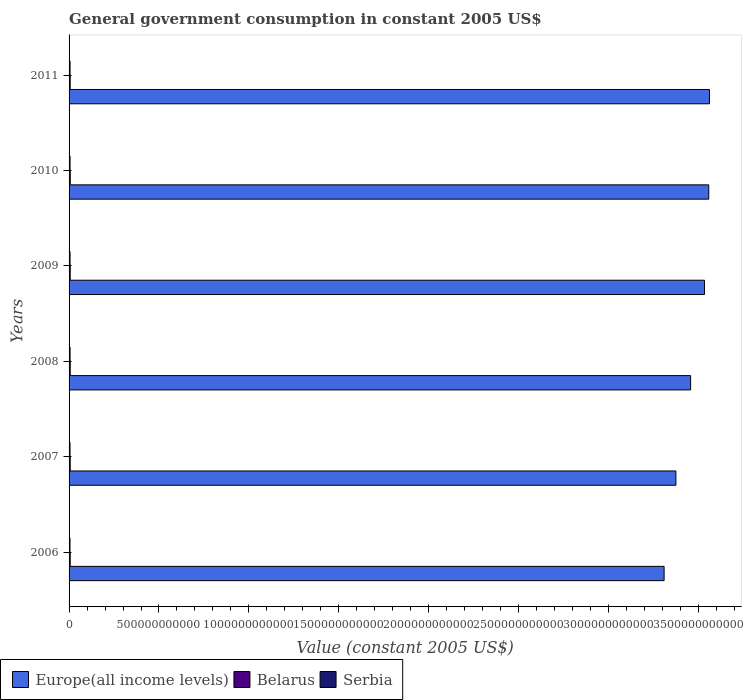How many different coloured bars are there?
Provide a short and direct response. 3. Are the number of bars per tick equal to the number of legend labels?
Offer a very short reply. Yes. How many bars are there on the 2nd tick from the top?
Your answer should be very brief. 3. How many bars are there on the 5th tick from the bottom?
Ensure brevity in your answer.  3. What is the label of the 3rd group of bars from the top?
Provide a succinct answer. 2009. What is the government conusmption in Europe(all income levels) in 2009?
Offer a terse response. 3.53e+12. Across all years, what is the maximum government conusmption in Belarus?
Offer a terse response. 6.45e+09. Across all years, what is the minimum government conusmption in Belarus?
Ensure brevity in your answer.  6.22e+09. In which year was the government conusmption in Europe(all income levels) minimum?
Offer a very short reply. 2006. What is the total government conusmption in Belarus in the graph?
Ensure brevity in your answer.  3.77e+1. What is the difference between the government conusmption in Serbia in 2006 and that in 2011?
Keep it short and to the point. -2.69e+08. What is the difference between the government conusmption in Serbia in 2006 and the government conusmption in Europe(all income levels) in 2009?
Keep it short and to the point. -3.53e+12. What is the average government conusmption in Serbia per year?
Provide a short and direct response. 5.38e+09. In the year 2008, what is the difference between the government conusmption in Belarus and government conusmption in Europe(all income levels)?
Give a very brief answer. -3.45e+12. What is the ratio of the government conusmption in Europe(all income levels) in 2009 to that in 2011?
Provide a short and direct response. 0.99. What is the difference between the highest and the second highest government conusmption in Europe(all income levels)?
Keep it short and to the point. 4.00e+09. What is the difference between the highest and the lowest government conusmption in Serbia?
Provide a succinct answer. 3.10e+08. In how many years, is the government conusmption in Europe(all income levels) greater than the average government conusmption in Europe(all income levels) taken over all years?
Ensure brevity in your answer.  3. What does the 2nd bar from the top in 2008 represents?
Your answer should be compact. Belarus. What does the 1st bar from the bottom in 2009 represents?
Provide a succinct answer. Europe(all income levels). What is the difference between two consecutive major ticks on the X-axis?
Give a very brief answer. 5.00e+11. Are the values on the major ticks of X-axis written in scientific E-notation?
Keep it short and to the point. No. Does the graph contain any zero values?
Your answer should be very brief. No. Does the graph contain grids?
Your answer should be very brief. No. Where does the legend appear in the graph?
Provide a succinct answer. Bottom left. What is the title of the graph?
Offer a very short reply. General government consumption in constant 2005 US$. What is the label or title of the X-axis?
Make the answer very short. Value (constant 2005 US$). What is the label or title of the Y-axis?
Provide a short and direct response. Years. What is the Value (constant 2005 US$) of Europe(all income levels) in 2006?
Offer a terse response. 3.31e+12. What is the Value (constant 2005 US$) in Belarus in 2006?
Make the answer very short. 6.27e+09. What is the Value (constant 2005 US$) in Serbia in 2006?
Make the answer very short. 5.20e+09. What is the Value (constant 2005 US$) of Europe(all income levels) in 2007?
Give a very brief answer. 3.37e+12. What is the Value (constant 2005 US$) of Belarus in 2007?
Provide a short and direct response. 6.24e+09. What is the Value (constant 2005 US$) in Serbia in 2007?
Give a very brief answer. 5.29e+09. What is the Value (constant 2005 US$) of Europe(all income levels) in 2008?
Ensure brevity in your answer.  3.46e+12. What is the Value (constant 2005 US$) in Belarus in 2008?
Your answer should be compact. 6.26e+09. What is the Value (constant 2005 US$) of Serbia in 2008?
Offer a very short reply. 5.51e+09. What is the Value (constant 2005 US$) of Europe(all income levels) in 2009?
Ensure brevity in your answer.  3.53e+12. What is the Value (constant 2005 US$) in Belarus in 2009?
Ensure brevity in your answer.  6.25e+09. What is the Value (constant 2005 US$) of Serbia in 2009?
Provide a succinct answer. 5.41e+09. What is the Value (constant 2005 US$) of Europe(all income levels) in 2010?
Give a very brief answer. 3.56e+12. What is the Value (constant 2005 US$) of Belarus in 2010?
Your answer should be compact. 6.45e+09. What is the Value (constant 2005 US$) in Serbia in 2010?
Ensure brevity in your answer.  5.42e+09. What is the Value (constant 2005 US$) in Europe(all income levels) in 2011?
Your response must be concise. 3.56e+12. What is the Value (constant 2005 US$) of Belarus in 2011?
Offer a very short reply. 6.22e+09. What is the Value (constant 2005 US$) in Serbia in 2011?
Your answer should be compact. 5.47e+09. Across all years, what is the maximum Value (constant 2005 US$) in Europe(all income levels)?
Offer a very short reply. 3.56e+12. Across all years, what is the maximum Value (constant 2005 US$) of Belarus?
Provide a succinct answer. 6.45e+09. Across all years, what is the maximum Value (constant 2005 US$) of Serbia?
Offer a terse response. 5.51e+09. Across all years, what is the minimum Value (constant 2005 US$) of Europe(all income levels)?
Give a very brief answer. 3.31e+12. Across all years, what is the minimum Value (constant 2005 US$) in Belarus?
Your response must be concise. 6.22e+09. Across all years, what is the minimum Value (constant 2005 US$) in Serbia?
Make the answer very short. 5.20e+09. What is the total Value (constant 2005 US$) of Europe(all income levels) in the graph?
Keep it short and to the point. 2.08e+13. What is the total Value (constant 2005 US$) in Belarus in the graph?
Your answer should be very brief. 3.77e+1. What is the total Value (constant 2005 US$) of Serbia in the graph?
Offer a terse response. 3.23e+1. What is the difference between the Value (constant 2005 US$) in Europe(all income levels) in 2006 and that in 2007?
Give a very brief answer. -6.56e+1. What is the difference between the Value (constant 2005 US$) in Belarus in 2006 and that in 2007?
Give a very brief answer. 3.20e+07. What is the difference between the Value (constant 2005 US$) of Serbia in 2006 and that in 2007?
Provide a short and direct response. -9.74e+07. What is the difference between the Value (constant 2005 US$) in Europe(all income levels) in 2006 and that in 2008?
Make the answer very short. -1.47e+11. What is the difference between the Value (constant 2005 US$) in Belarus in 2006 and that in 2008?
Give a very brief answer. 1.20e+07. What is the difference between the Value (constant 2005 US$) of Serbia in 2006 and that in 2008?
Give a very brief answer. -3.10e+08. What is the difference between the Value (constant 2005 US$) of Europe(all income levels) in 2006 and that in 2009?
Your response must be concise. -2.24e+11. What is the difference between the Value (constant 2005 US$) of Belarus in 2006 and that in 2009?
Provide a short and direct response. 1.70e+07. What is the difference between the Value (constant 2005 US$) in Serbia in 2006 and that in 2009?
Keep it short and to the point. -2.16e+08. What is the difference between the Value (constant 2005 US$) in Europe(all income levels) in 2006 and that in 2010?
Keep it short and to the point. -2.48e+11. What is the difference between the Value (constant 2005 US$) of Belarus in 2006 and that in 2010?
Ensure brevity in your answer.  -1.78e+08. What is the difference between the Value (constant 2005 US$) in Serbia in 2006 and that in 2010?
Keep it short and to the point. -2.20e+08. What is the difference between the Value (constant 2005 US$) in Europe(all income levels) in 2006 and that in 2011?
Give a very brief answer. -2.52e+11. What is the difference between the Value (constant 2005 US$) of Belarus in 2006 and that in 2011?
Offer a very short reply. 5.12e+07. What is the difference between the Value (constant 2005 US$) of Serbia in 2006 and that in 2011?
Offer a very short reply. -2.69e+08. What is the difference between the Value (constant 2005 US$) of Europe(all income levels) in 2007 and that in 2008?
Make the answer very short. -8.17e+1. What is the difference between the Value (constant 2005 US$) in Belarus in 2007 and that in 2008?
Your answer should be very brief. -2.00e+07. What is the difference between the Value (constant 2005 US$) in Serbia in 2007 and that in 2008?
Make the answer very short. -2.12e+08. What is the difference between the Value (constant 2005 US$) in Europe(all income levels) in 2007 and that in 2009?
Ensure brevity in your answer.  -1.59e+11. What is the difference between the Value (constant 2005 US$) in Belarus in 2007 and that in 2009?
Offer a terse response. -1.50e+07. What is the difference between the Value (constant 2005 US$) of Serbia in 2007 and that in 2009?
Provide a short and direct response. -1.18e+08. What is the difference between the Value (constant 2005 US$) in Europe(all income levels) in 2007 and that in 2010?
Give a very brief answer. -1.83e+11. What is the difference between the Value (constant 2005 US$) in Belarus in 2007 and that in 2010?
Your answer should be compact. -2.10e+08. What is the difference between the Value (constant 2005 US$) of Serbia in 2007 and that in 2010?
Make the answer very short. -1.23e+08. What is the difference between the Value (constant 2005 US$) of Europe(all income levels) in 2007 and that in 2011?
Your answer should be very brief. -1.87e+11. What is the difference between the Value (constant 2005 US$) in Belarus in 2007 and that in 2011?
Keep it short and to the point. 1.92e+07. What is the difference between the Value (constant 2005 US$) of Serbia in 2007 and that in 2011?
Give a very brief answer. -1.71e+08. What is the difference between the Value (constant 2005 US$) of Europe(all income levels) in 2008 and that in 2009?
Keep it short and to the point. -7.71e+1. What is the difference between the Value (constant 2005 US$) in Belarus in 2008 and that in 2009?
Your response must be concise. 5.01e+06. What is the difference between the Value (constant 2005 US$) of Serbia in 2008 and that in 2009?
Provide a succinct answer. 9.37e+07. What is the difference between the Value (constant 2005 US$) in Europe(all income levels) in 2008 and that in 2010?
Keep it short and to the point. -1.01e+11. What is the difference between the Value (constant 2005 US$) of Belarus in 2008 and that in 2010?
Offer a very short reply. -1.90e+08. What is the difference between the Value (constant 2005 US$) in Serbia in 2008 and that in 2010?
Your answer should be compact. 8.92e+07. What is the difference between the Value (constant 2005 US$) of Europe(all income levels) in 2008 and that in 2011?
Provide a short and direct response. -1.05e+11. What is the difference between the Value (constant 2005 US$) in Belarus in 2008 and that in 2011?
Offer a terse response. 3.92e+07. What is the difference between the Value (constant 2005 US$) of Serbia in 2008 and that in 2011?
Provide a short and direct response. 4.07e+07. What is the difference between the Value (constant 2005 US$) in Europe(all income levels) in 2009 and that in 2010?
Offer a terse response. -2.38e+1. What is the difference between the Value (constant 2005 US$) of Belarus in 2009 and that in 2010?
Make the answer very short. -1.96e+08. What is the difference between the Value (constant 2005 US$) in Serbia in 2009 and that in 2010?
Provide a short and direct response. -4.51e+06. What is the difference between the Value (constant 2005 US$) of Europe(all income levels) in 2009 and that in 2011?
Provide a succinct answer. -2.78e+1. What is the difference between the Value (constant 2005 US$) in Belarus in 2009 and that in 2011?
Keep it short and to the point. 3.42e+07. What is the difference between the Value (constant 2005 US$) in Serbia in 2009 and that in 2011?
Make the answer very short. -5.30e+07. What is the difference between the Value (constant 2005 US$) of Europe(all income levels) in 2010 and that in 2011?
Your answer should be compact. -4.00e+09. What is the difference between the Value (constant 2005 US$) in Belarus in 2010 and that in 2011?
Your answer should be very brief. 2.30e+08. What is the difference between the Value (constant 2005 US$) in Serbia in 2010 and that in 2011?
Keep it short and to the point. -4.85e+07. What is the difference between the Value (constant 2005 US$) of Europe(all income levels) in 2006 and the Value (constant 2005 US$) of Belarus in 2007?
Give a very brief answer. 3.30e+12. What is the difference between the Value (constant 2005 US$) of Europe(all income levels) in 2006 and the Value (constant 2005 US$) of Serbia in 2007?
Ensure brevity in your answer.  3.30e+12. What is the difference between the Value (constant 2005 US$) in Belarus in 2006 and the Value (constant 2005 US$) in Serbia in 2007?
Provide a short and direct response. 9.75e+08. What is the difference between the Value (constant 2005 US$) of Europe(all income levels) in 2006 and the Value (constant 2005 US$) of Belarus in 2008?
Your answer should be compact. 3.30e+12. What is the difference between the Value (constant 2005 US$) in Europe(all income levels) in 2006 and the Value (constant 2005 US$) in Serbia in 2008?
Give a very brief answer. 3.30e+12. What is the difference between the Value (constant 2005 US$) in Belarus in 2006 and the Value (constant 2005 US$) in Serbia in 2008?
Offer a terse response. 7.63e+08. What is the difference between the Value (constant 2005 US$) in Europe(all income levels) in 2006 and the Value (constant 2005 US$) in Belarus in 2009?
Your answer should be very brief. 3.30e+12. What is the difference between the Value (constant 2005 US$) in Europe(all income levels) in 2006 and the Value (constant 2005 US$) in Serbia in 2009?
Keep it short and to the point. 3.30e+12. What is the difference between the Value (constant 2005 US$) in Belarus in 2006 and the Value (constant 2005 US$) in Serbia in 2009?
Provide a short and direct response. 8.57e+08. What is the difference between the Value (constant 2005 US$) of Europe(all income levels) in 2006 and the Value (constant 2005 US$) of Belarus in 2010?
Provide a succinct answer. 3.30e+12. What is the difference between the Value (constant 2005 US$) in Europe(all income levels) in 2006 and the Value (constant 2005 US$) in Serbia in 2010?
Provide a succinct answer. 3.30e+12. What is the difference between the Value (constant 2005 US$) in Belarus in 2006 and the Value (constant 2005 US$) in Serbia in 2010?
Give a very brief answer. 8.52e+08. What is the difference between the Value (constant 2005 US$) of Europe(all income levels) in 2006 and the Value (constant 2005 US$) of Belarus in 2011?
Ensure brevity in your answer.  3.30e+12. What is the difference between the Value (constant 2005 US$) of Europe(all income levels) in 2006 and the Value (constant 2005 US$) of Serbia in 2011?
Offer a very short reply. 3.30e+12. What is the difference between the Value (constant 2005 US$) in Belarus in 2006 and the Value (constant 2005 US$) in Serbia in 2011?
Give a very brief answer. 8.04e+08. What is the difference between the Value (constant 2005 US$) of Europe(all income levels) in 2007 and the Value (constant 2005 US$) of Belarus in 2008?
Give a very brief answer. 3.37e+12. What is the difference between the Value (constant 2005 US$) in Europe(all income levels) in 2007 and the Value (constant 2005 US$) in Serbia in 2008?
Provide a succinct answer. 3.37e+12. What is the difference between the Value (constant 2005 US$) of Belarus in 2007 and the Value (constant 2005 US$) of Serbia in 2008?
Your response must be concise. 7.31e+08. What is the difference between the Value (constant 2005 US$) of Europe(all income levels) in 2007 and the Value (constant 2005 US$) of Belarus in 2009?
Offer a very short reply. 3.37e+12. What is the difference between the Value (constant 2005 US$) in Europe(all income levels) in 2007 and the Value (constant 2005 US$) in Serbia in 2009?
Your response must be concise. 3.37e+12. What is the difference between the Value (constant 2005 US$) of Belarus in 2007 and the Value (constant 2005 US$) of Serbia in 2009?
Provide a short and direct response. 8.25e+08. What is the difference between the Value (constant 2005 US$) in Europe(all income levels) in 2007 and the Value (constant 2005 US$) in Belarus in 2010?
Provide a short and direct response. 3.37e+12. What is the difference between the Value (constant 2005 US$) in Europe(all income levels) in 2007 and the Value (constant 2005 US$) in Serbia in 2010?
Give a very brief answer. 3.37e+12. What is the difference between the Value (constant 2005 US$) in Belarus in 2007 and the Value (constant 2005 US$) in Serbia in 2010?
Provide a succinct answer. 8.20e+08. What is the difference between the Value (constant 2005 US$) of Europe(all income levels) in 2007 and the Value (constant 2005 US$) of Belarus in 2011?
Provide a succinct answer. 3.37e+12. What is the difference between the Value (constant 2005 US$) of Europe(all income levels) in 2007 and the Value (constant 2005 US$) of Serbia in 2011?
Your response must be concise. 3.37e+12. What is the difference between the Value (constant 2005 US$) of Belarus in 2007 and the Value (constant 2005 US$) of Serbia in 2011?
Provide a succinct answer. 7.72e+08. What is the difference between the Value (constant 2005 US$) in Europe(all income levels) in 2008 and the Value (constant 2005 US$) in Belarus in 2009?
Your answer should be very brief. 3.45e+12. What is the difference between the Value (constant 2005 US$) in Europe(all income levels) in 2008 and the Value (constant 2005 US$) in Serbia in 2009?
Keep it short and to the point. 3.45e+12. What is the difference between the Value (constant 2005 US$) in Belarus in 2008 and the Value (constant 2005 US$) in Serbia in 2009?
Offer a terse response. 8.45e+08. What is the difference between the Value (constant 2005 US$) of Europe(all income levels) in 2008 and the Value (constant 2005 US$) of Belarus in 2010?
Make the answer very short. 3.45e+12. What is the difference between the Value (constant 2005 US$) in Europe(all income levels) in 2008 and the Value (constant 2005 US$) in Serbia in 2010?
Give a very brief answer. 3.45e+12. What is the difference between the Value (constant 2005 US$) in Belarus in 2008 and the Value (constant 2005 US$) in Serbia in 2010?
Offer a terse response. 8.40e+08. What is the difference between the Value (constant 2005 US$) of Europe(all income levels) in 2008 and the Value (constant 2005 US$) of Belarus in 2011?
Provide a short and direct response. 3.45e+12. What is the difference between the Value (constant 2005 US$) in Europe(all income levels) in 2008 and the Value (constant 2005 US$) in Serbia in 2011?
Provide a short and direct response. 3.45e+12. What is the difference between the Value (constant 2005 US$) of Belarus in 2008 and the Value (constant 2005 US$) of Serbia in 2011?
Your response must be concise. 7.92e+08. What is the difference between the Value (constant 2005 US$) of Europe(all income levels) in 2009 and the Value (constant 2005 US$) of Belarus in 2010?
Your response must be concise. 3.53e+12. What is the difference between the Value (constant 2005 US$) of Europe(all income levels) in 2009 and the Value (constant 2005 US$) of Serbia in 2010?
Your answer should be compact. 3.53e+12. What is the difference between the Value (constant 2005 US$) in Belarus in 2009 and the Value (constant 2005 US$) in Serbia in 2010?
Provide a succinct answer. 8.35e+08. What is the difference between the Value (constant 2005 US$) in Europe(all income levels) in 2009 and the Value (constant 2005 US$) in Belarus in 2011?
Your response must be concise. 3.53e+12. What is the difference between the Value (constant 2005 US$) in Europe(all income levels) in 2009 and the Value (constant 2005 US$) in Serbia in 2011?
Your answer should be very brief. 3.53e+12. What is the difference between the Value (constant 2005 US$) of Belarus in 2009 and the Value (constant 2005 US$) of Serbia in 2011?
Offer a very short reply. 7.87e+08. What is the difference between the Value (constant 2005 US$) in Europe(all income levels) in 2010 and the Value (constant 2005 US$) in Belarus in 2011?
Provide a short and direct response. 3.55e+12. What is the difference between the Value (constant 2005 US$) in Europe(all income levels) in 2010 and the Value (constant 2005 US$) in Serbia in 2011?
Offer a terse response. 3.55e+12. What is the difference between the Value (constant 2005 US$) of Belarus in 2010 and the Value (constant 2005 US$) of Serbia in 2011?
Provide a succinct answer. 9.82e+08. What is the average Value (constant 2005 US$) in Europe(all income levels) per year?
Ensure brevity in your answer.  3.47e+12. What is the average Value (constant 2005 US$) of Belarus per year?
Your answer should be very brief. 6.28e+09. What is the average Value (constant 2005 US$) in Serbia per year?
Your response must be concise. 5.38e+09. In the year 2006, what is the difference between the Value (constant 2005 US$) of Europe(all income levels) and Value (constant 2005 US$) of Belarus?
Your response must be concise. 3.30e+12. In the year 2006, what is the difference between the Value (constant 2005 US$) in Europe(all income levels) and Value (constant 2005 US$) in Serbia?
Offer a very short reply. 3.30e+12. In the year 2006, what is the difference between the Value (constant 2005 US$) in Belarus and Value (constant 2005 US$) in Serbia?
Offer a very short reply. 1.07e+09. In the year 2007, what is the difference between the Value (constant 2005 US$) of Europe(all income levels) and Value (constant 2005 US$) of Belarus?
Give a very brief answer. 3.37e+12. In the year 2007, what is the difference between the Value (constant 2005 US$) in Europe(all income levels) and Value (constant 2005 US$) in Serbia?
Make the answer very short. 3.37e+12. In the year 2007, what is the difference between the Value (constant 2005 US$) of Belarus and Value (constant 2005 US$) of Serbia?
Ensure brevity in your answer.  9.43e+08. In the year 2008, what is the difference between the Value (constant 2005 US$) of Europe(all income levels) and Value (constant 2005 US$) of Belarus?
Your response must be concise. 3.45e+12. In the year 2008, what is the difference between the Value (constant 2005 US$) in Europe(all income levels) and Value (constant 2005 US$) in Serbia?
Your response must be concise. 3.45e+12. In the year 2008, what is the difference between the Value (constant 2005 US$) of Belarus and Value (constant 2005 US$) of Serbia?
Keep it short and to the point. 7.51e+08. In the year 2009, what is the difference between the Value (constant 2005 US$) in Europe(all income levels) and Value (constant 2005 US$) in Belarus?
Offer a terse response. 3.53e+12. In the year 2009, what is the difference between the Value (constant 2005 US$) in Europe(all income levels) and Value (constant 2005 US$) in Serbia?
Make the answer very short. 3.53e+12. In the year 2009, what is the difference between the Value (constant 2005 US$) of Belarus and Value (constant 2005 US$) of Serbia?
Offer a very short reply. 8.40e+08. In the year 2010, what is the difference between the Value (constant 2005 US$) in Europe(all income levels) and Value (constant 2005 US$) in Belarus?
Offer a very short reply. 3.55e+12. In the year 2010, what is the difference between the Value (constant 2005 US$) in Europe(all income levels) and Value (constant 2005 US$) in Serbia?
Keep it short and to the point. 3.55e+12. In the year 2010, what is the difference between the Value (constant 2005 US$) in Belarus and Value (constant 2005 US$) in Serbia?
Make the answer very short. 1.03e+09. In the year 2011, what is the difference between the Value (constant 2005 US$) of Europe(all income levels) and Value (constant 2005 US$) of Belarus?
Your answer should be very brief. 3.55e+12. In the year 2011, what is the difference between the Value (constant 2005 US$) of Europe(all income levels) and Value (constant 2005 US$) of Serbia?
Your answer should be compact. 3.56e+12. In the year 2011, what is the difference between the Value (constant 2005 US$) in Belarus and Value (constant 2005 US$) in Serbia?
Your response must be concise. 7.53e+08. What is the ratio of the Value (constant 2005 US$) of Europe(all income levels) in 2006 to that in 2007?
Your response must be concise. 0.98. What is the ratio of the Value (constant 2005 US$) of Serbia in 2006 to that in 2007?
Provide a short and direct response. 0.98. What is the ratio of the Value (constant 2005 US$) of Europe(all income levels) in 2006 to that in 2008?
Your response must be concise. 0.96. What is the ratio of the Value (constant 2005 US$) of Belarus in 2006 to that in 2008?
Offer a very short reply. 1. What is the ratio of the Value (constant 2005 US$) of Serbia in 2006 to that in 2008?
Ensure brevity in your answer.  0.94. What is the ratio of the Value (constant 2005 US$) of Europe(all income levels) in 2006 to that in 2009?
Provide a short and direct response. 0.94. What is the ratio of the Value (constant 2005 US$) in Serbia in 2006 to that in 2009?
Provide a short and direct response. 0.96. What is the ratio of the Value (constant 2005 US$) in Europe(all income levels) in 2006 to that in 2010?
Offer a very short reply. 0.93. What is the ratio of the Value (constant 2005 US$) in Belarus in 2006 to that in 2010?
Your answer should be very brief. 0.97. What is the ratio of the Value (constant 2005 US$) in Serbia in 2006 to that in 2010?
Give a very brief answer. 0.96. What is the ratio of the Value (constant 2005 US$) of Europe(all income levels) in 2006 to that in 2011?
Offer a very short reply. 0.93. What is the ratio of the Value (constant 2005 US$) in Belarus in 2006 to that in 2011?
Offer a very short reply. 1.01. What is the ratio of the Value (constant 2005 US$) in Serbia in 2006 to that in 2011?
Offer a very short reply. 0.95. What is the ratio of the Value (constant 2005 US$) in Europe(all income levels) in 2007 to that in 2008?
Offer a terse response. 0.98. What is the ratio of the Value (constant 2005 US$) in Belarus in 2007 to that in 2008?
Your response must be concise. 1. What is the ratio of the Value (constant 2005 US$) in Serbia in 2007 to that in 2008?
Offer a very short reply. 0.96. What is the ratio of the Value (constant 2005 US$) in Europe(all income levels) in 2007 to that in 2009?
Your answer should be compact. 0.95. What is the ratio of the Value (constant 2005 US$) of Serbia in 2007 to that in 2009?
Your response must be concise. 0.98. What is the ratio of the Value (constant 2005 US$) of Europe(all income levels) in 2007 to that in 2010?
Your response must be concise. 0.95. What is the ratio of the Value (constant 2005 US$) in Belarus in 2007 to that in 2010?
Provide a short and direct response. 0.97. What is the ratio of the Value (constant 2005 US$) in Serbia in 2007 to that in 2010?
Provide a succinct answer. 0.98. What is the ratio of the Value (constant 2005 US$) of Europe(all income levels) in 2007 to that in 2011?
Make the answer very short. 0.95. What is the ratio of the Value (constant 2005 US$) in Serbia in 2007 to that in 2011?
Your response must be concise. 0.97. What is the ratio of the Value (constant 2005 US$) in Europe(all income levels) in 2008 to that in 2009?
Make the answer very short. 0.98. What is the ratio of the Value (constant 2005 US$) of Belarus in 2008 to that in 2009?
Your answer should be very brief. 1. What is the ratio of the Value (constant 2005 US$) of Serbia in 2008 to that in 2009?
Provide a short and direct response. 1.02. What is the ratio of the Value (constant 2005 US$) in Europe(all income levels) in 2008 to that in 2010?
Your answer should be compact. 0.97. What is the ratio of the Value (constant 2005 US$) in Belarus in 2008 to that in 2010?
Offer a terse response. 0.97. What is the ratio of the Value (constant 2005 US$) of Serbia in 2008 to that in 2010?
Your response must be concise. 1.02. What is the ratio of the Value (constant 2005 US$) in Europe(all income levels) in 2008 to that in 2011?
Keep it short and to the point. 0.97. What is the ratio of the Value (constant 2005 US$) in Serbia in 2008 to that in 2011?
Offer a very short reply. 1.01. What is the ratio of the Value (constant 2005 US$) of Europe(all income levels) in 2009 to that in 2010?
Offer a terse response. 0.99. What is the ratio of the Value (constant 2005 US$) of Belarus in 2009 to that in 2010?
Provide a short and direct response. 0.97. What is the ratio of the Value (constant 2005 US$) of Europe(all income levels) in 2009 to that in 2011?
Provide a short and direct response. 0.99. What is the ratio of the Value (constant 2005 US$) of Belarus in 2009 to that in 2011?
Keep it short and to the point. 1.01. What is the ratio of the Value (constant 2005 US$) in Serbia in 2009 to that in 2011?
Provide a short and direct response. 0.99. What is the ratio of the Value (constant 2005 US$) of Belarus in 2010 to that in 2011?
Offer a very short reply. 1.04. What is the ratio of the Value (constant 2005 US$) of Serbia in 2010 to that in 2011?
Keep it short and to the point. 0.99. What is the difference between the highest and the second highest Value (constant 2005 US$) of Europe(all income levels)?
Keep it short and to the point. 4.00e+09. What is the difference between the highest and the second highest Value (constant 2005 US$) of Belarus?
Keep it short and to the point. 1.78e+08. What is the difference between the highest and the second highest Value (constant 2005 US$) in Serbia?
Your response must be concise. 4.07e+07. What is the difference between the highest and the lowest Value (constant 2005 US$) in Europe(all income levels)?
Provide a succinct answer. 2.52e+11. What is the difference between the highest and the lowest Value (constant 2005 US$) of Belarus?
Offer a terse response. 2.30e+08. What is the difference between the highest and the lowest Value (constant 2005 US$) of Serbia?
Offer a very short reply. 3.10e+08. 